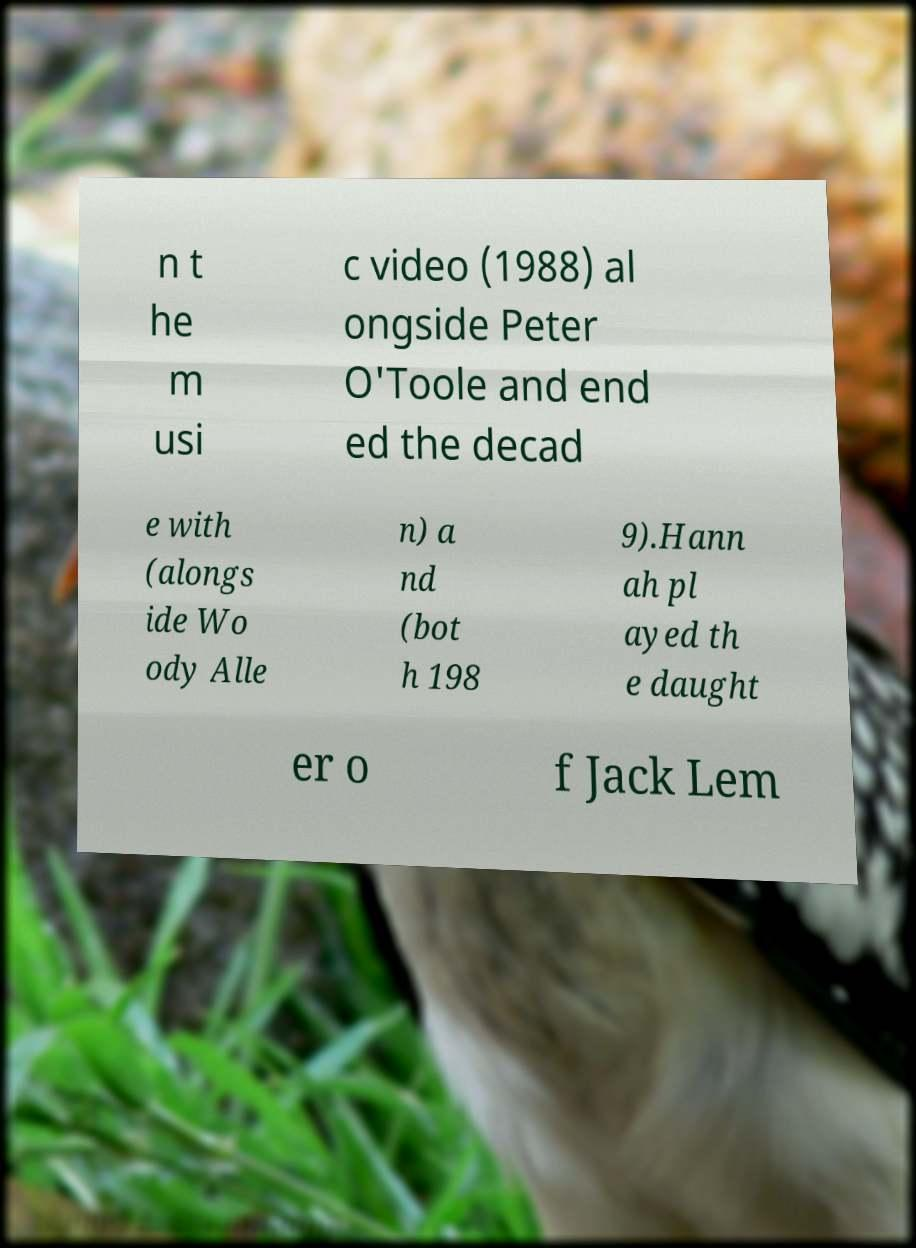For documentation purposes, I need the text within this image transcribed. Could you provide that? n t he m usi c video (1988) al ongside Peter O'Toole and end ed the decad e with (alongs ide Wo ody Alle n) a nd (bot h 198 9).Hann ah pl ayed th e daught er o f Jack Lem 